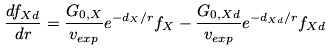Convert formula to latex. <formula><loc_0><loc_0><loc_500><loc_500>\frac { { d } f _ { X d } } { { d } r } = \frac { G _ { 0 , X } } { v _ { e x p } } { e } ^ { - d _ { X } / r } f _ { X } - \frac { G _ { 0 , X d } } { v _ { e x p } } { e } ^ { - d _ { X d } / r } f _ { X d }</formula> 